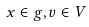Convert formula to latex. <formula><loc_0><loc_0><loc_500><loc_500>x \in g , v \in V</formula> 